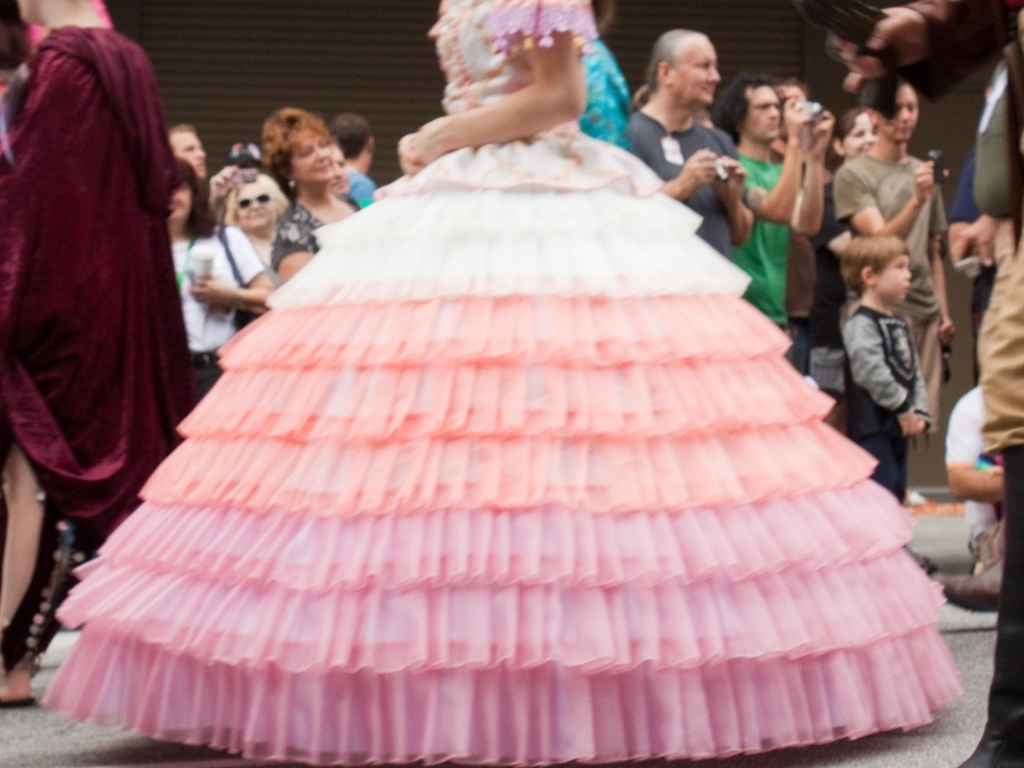What can you infer about the person wearing the large dress in the photo? The individual is likely part of the event's entertainment, wearing a costume designed to stand out and be visually striking. The size and style of the dress are exaggerated, which could mean this is a cultural festival, a historical reenactment, or a themed parade. The dress's vibrant colors and multiple layers suggest that the wearer is central to the event, and their ensemble is meant to convey a sense of drama and allure. 